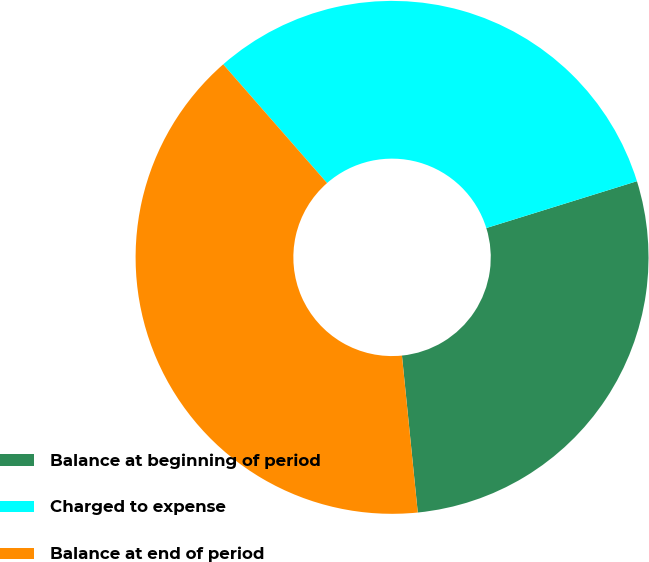Convert chart. <chart><loc_0><loc_0><loc_500><loc_500><pie_chart><fcel>Balance at beginning of period<fcel>Charged to expense<fcel>Balance at end of period<nl><fcel>28.2%<fcel>31.64%<fcel>40.16%<nl></chart> 